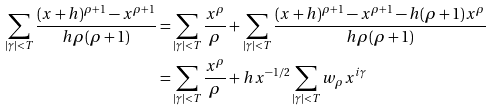<formula> <loc_0><loc_0><loc_500><loc_500>\sum _ { | \gamma | < T } \frac { ( x + h ) ^ { \rho + 1 } - x ^ { \rho + 1 } } { h \rho ( \rho + 1 ) } = & \sum _ { | \gamma | < T } \frac { x ^ { \rho } } { \rho } + \sum _ { | \gamma | < T } \frac { ( x + h ) ^ { \rho + 1 } - x ^ { \rho + 1 } - h ( \rho + 1 ) x ^ { \rho } } { h \rho ( \rho + 1 ) } \\ = & \sum _ { | \gamma | < T } \frac { x ^ { \rho } } { \rho } + h x ^ { - 1 / 2 } \sum _ { | \gamma | < T } w _ { \rho } x ^ { i \gamma }</formula> 